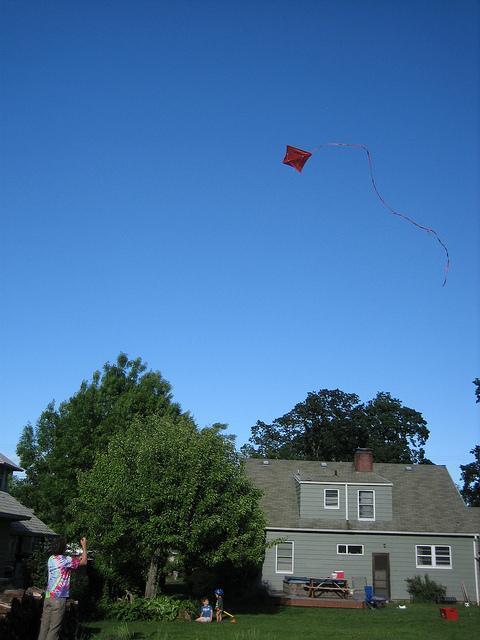How many satellite dishes are on the house?
Give a very brief answer. 0. How many oranges are in the picture?
Give a very brief answer. 0. 